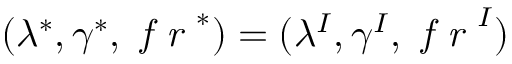<formula> <loc_0><loc_0><loc_500><loc_500>( \lambda ^ { * } , \gamma ^ { * } , f r ^ { * } ) = ( \lambda ^ { I } , \gamma ^ { I } , f r ^ { I } )</formula> 